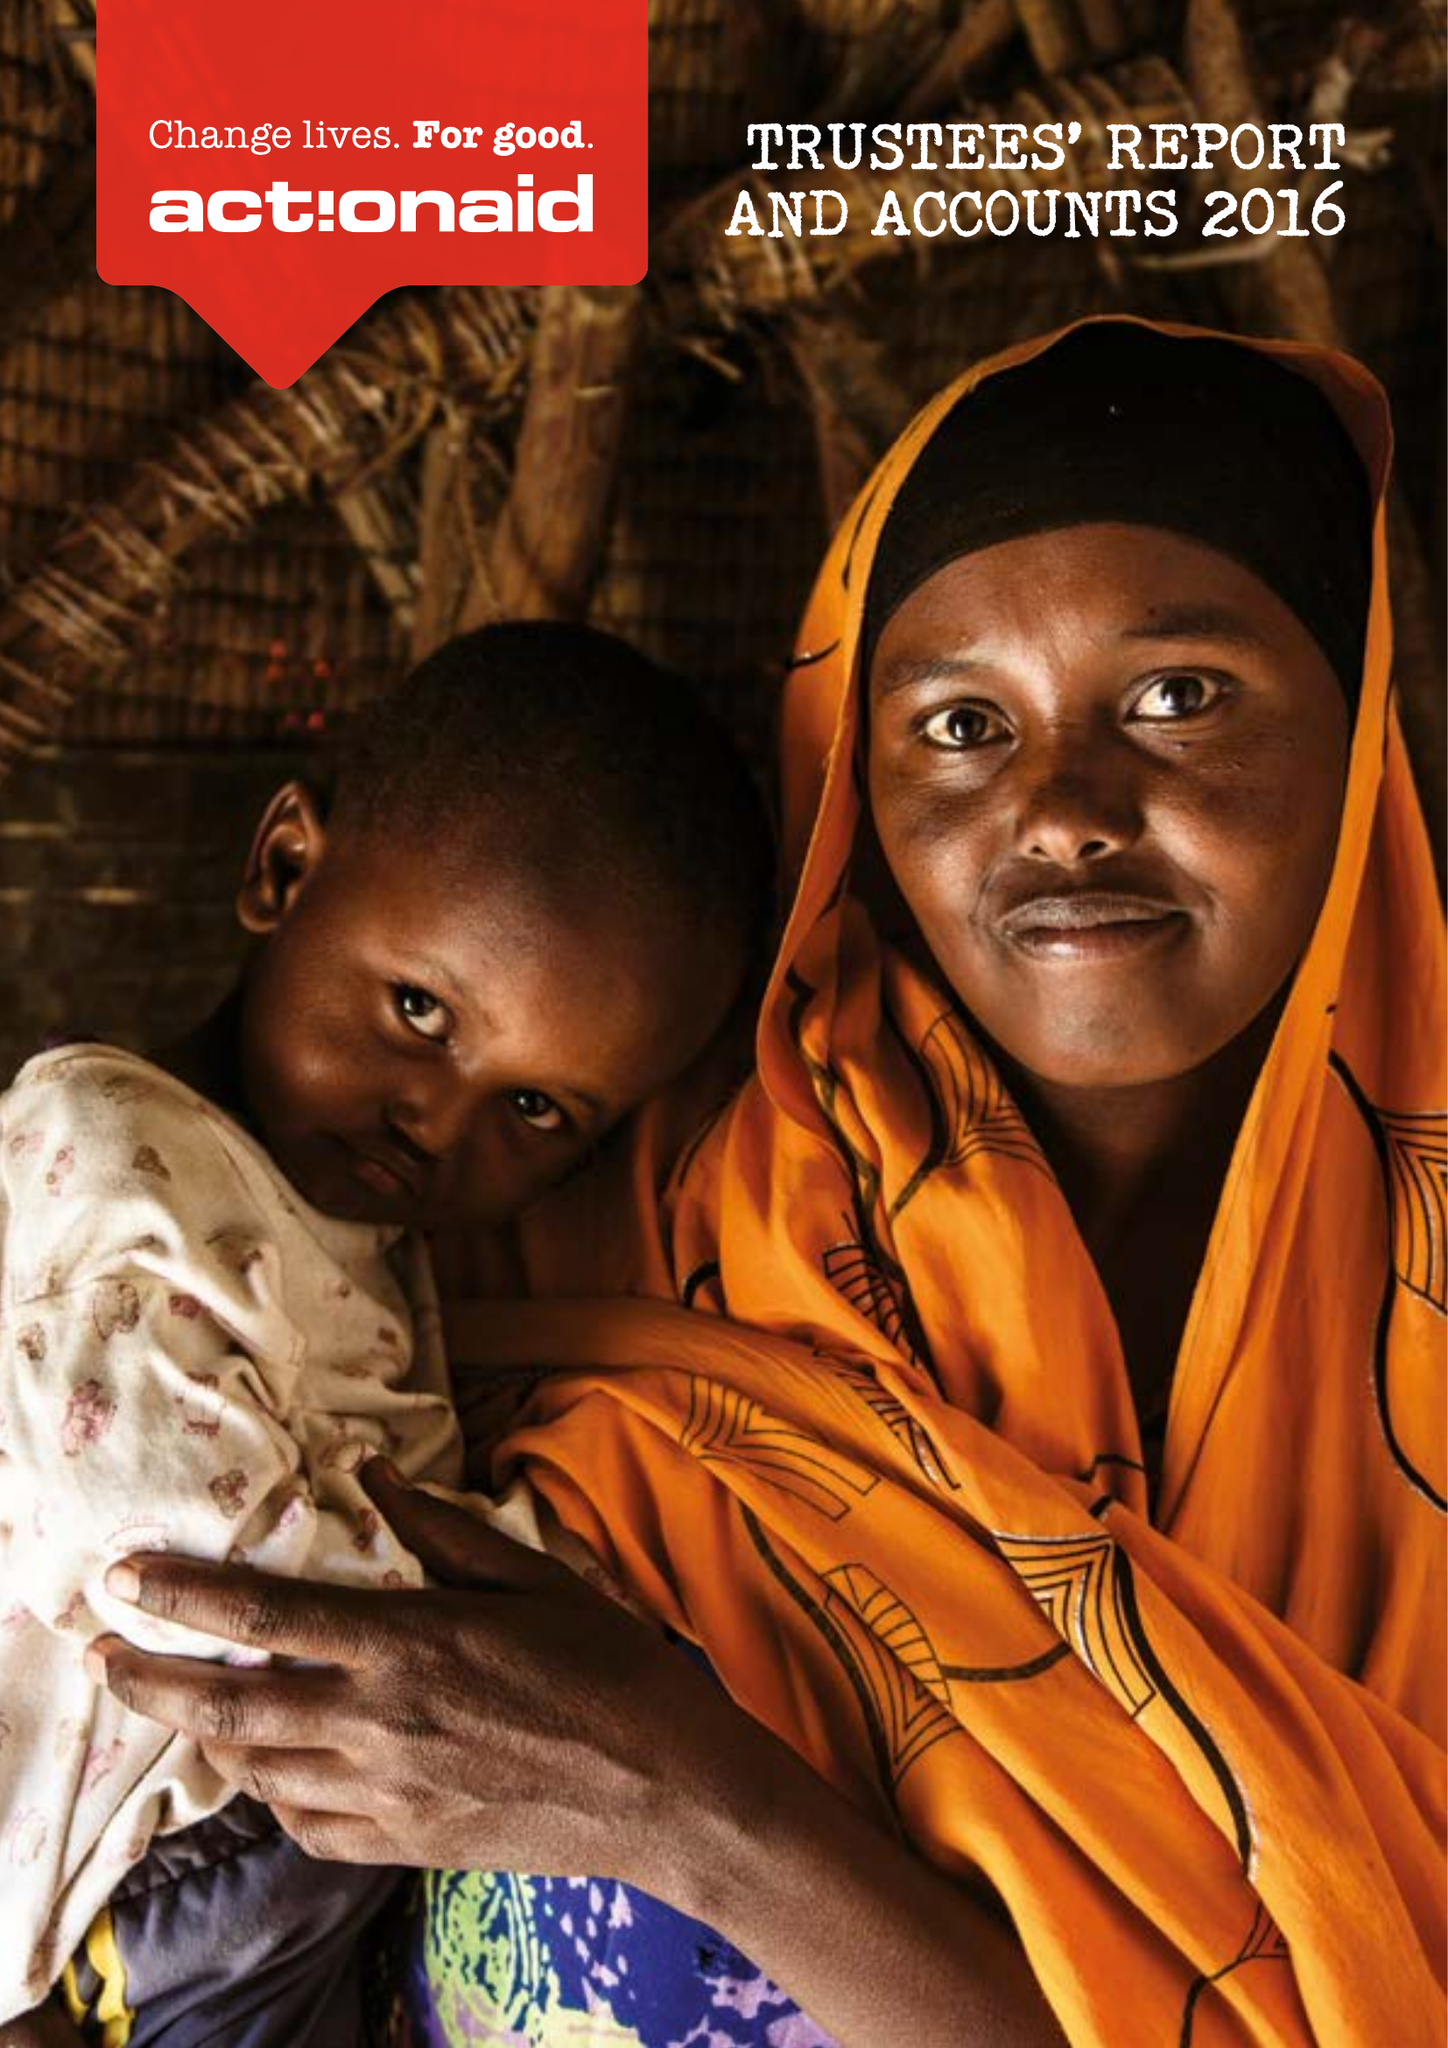What is the value for the spending_annually_in_british_pounds?
Answer the question using a single word or phrase. 58620000.00 